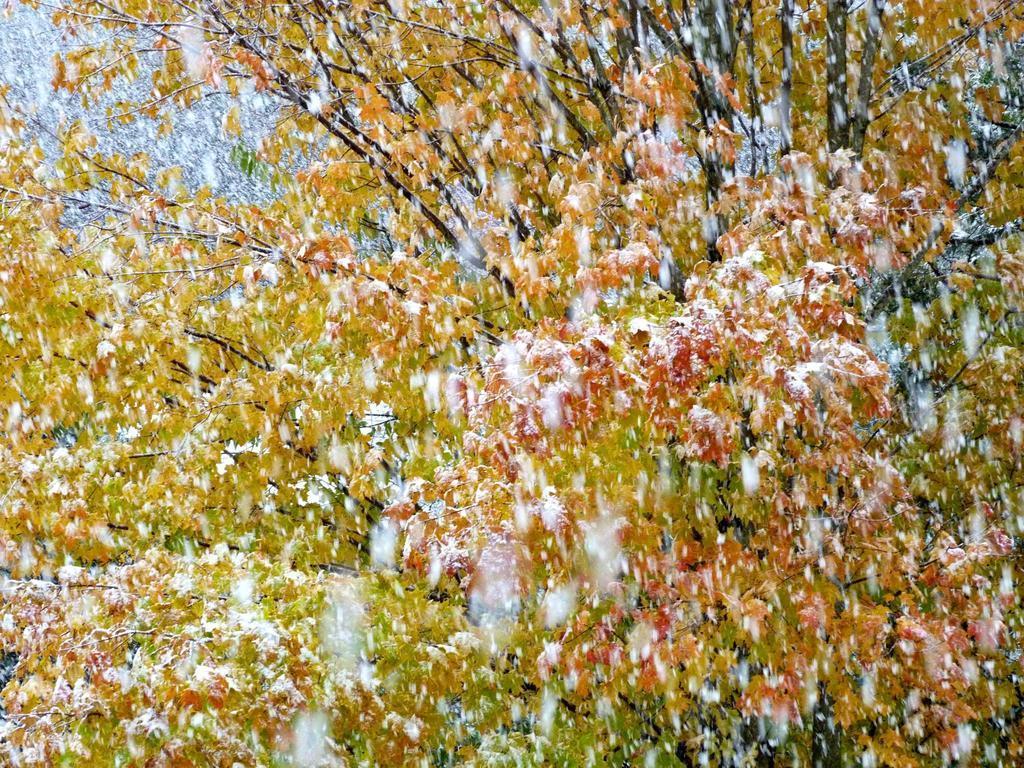How would you summarize this image in a sentence or two? In this picture we can see trees. 